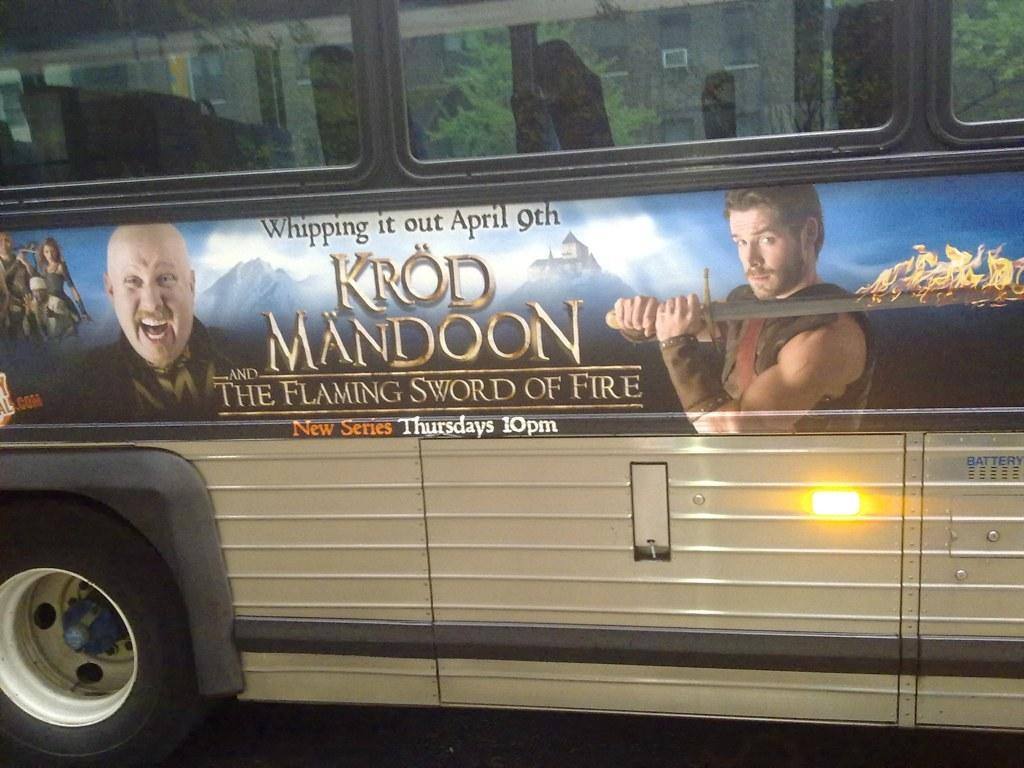What is the main subject of the image? The main subject of the image is a bus. What can be seen on the bus? There is text visible on the bus, and there are images of people on the bus. What is visible through the window of the bus? Trees are visible through the window of the bus. How many legs can be seen on the tramp in the image? There is no tramp present in the image; it features a bus with text and images of people. 